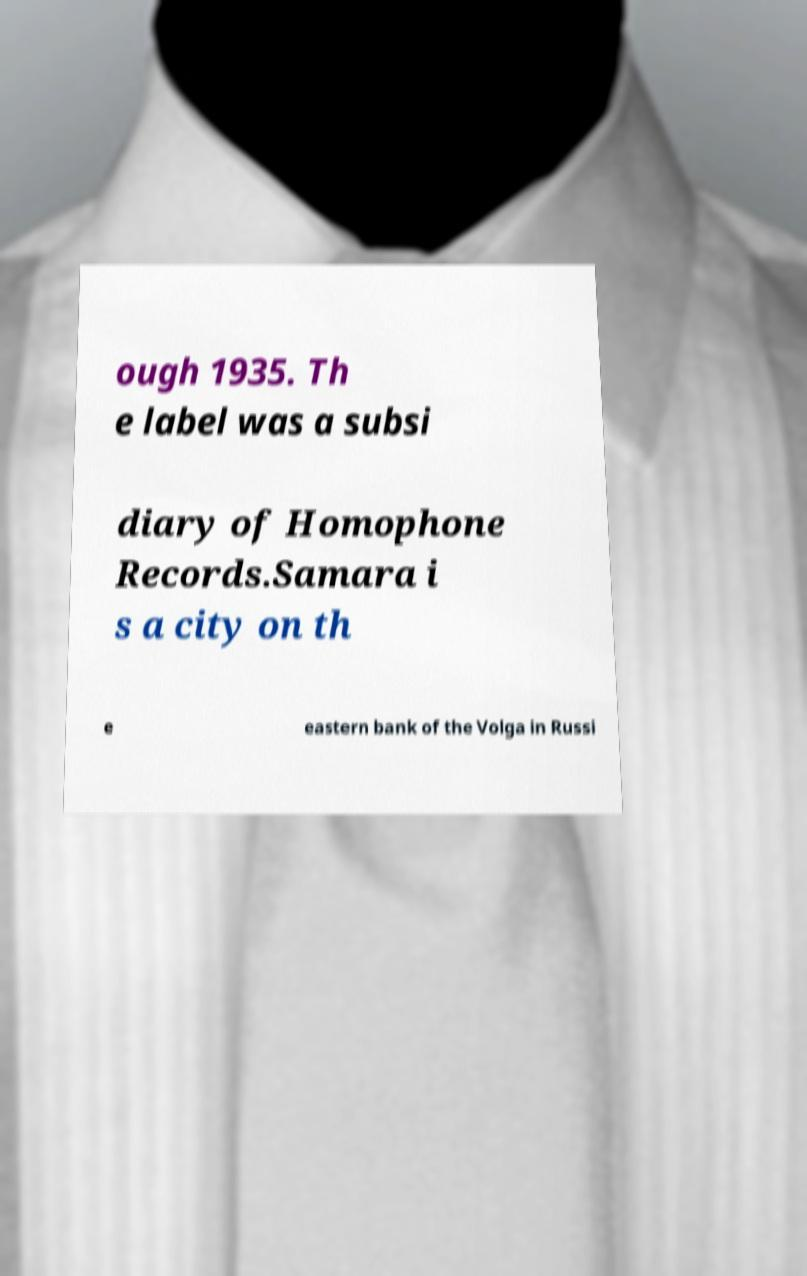For documentation purposes, I need the text within this image transcribed. Could you provide that? ough 1935. Th e label was a subsi diary of Homophone Records.Samara i s a city on th e eastern bank of the Volga in Russi 